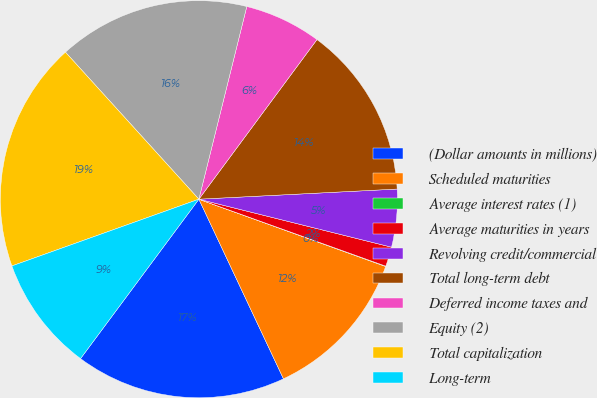<chart> <loc_0><loc_0><loc_500><loc_500><pie_chart><fcel>(Dollar amounts in millions)<fcel>Scheduled maturities<fcel>Average interest rates (1)<fcel>Average maturities in years<fcel>Revolving credit/commercial<fcel>Total long-term debt<fcel>Deferred income taxes and<fcel>Equity (2)<fcel>Total capitalization<fcel>Long-term<nl><fcel>17.17%<fcel>12.49%<fcel>0.03%<fcel>1.59%<fcel>4.7%<fcel>14.05%<fcel>6.26%<fcel>15.61%<fcel>18.73%<fcel>9.38%<nl></chart> 